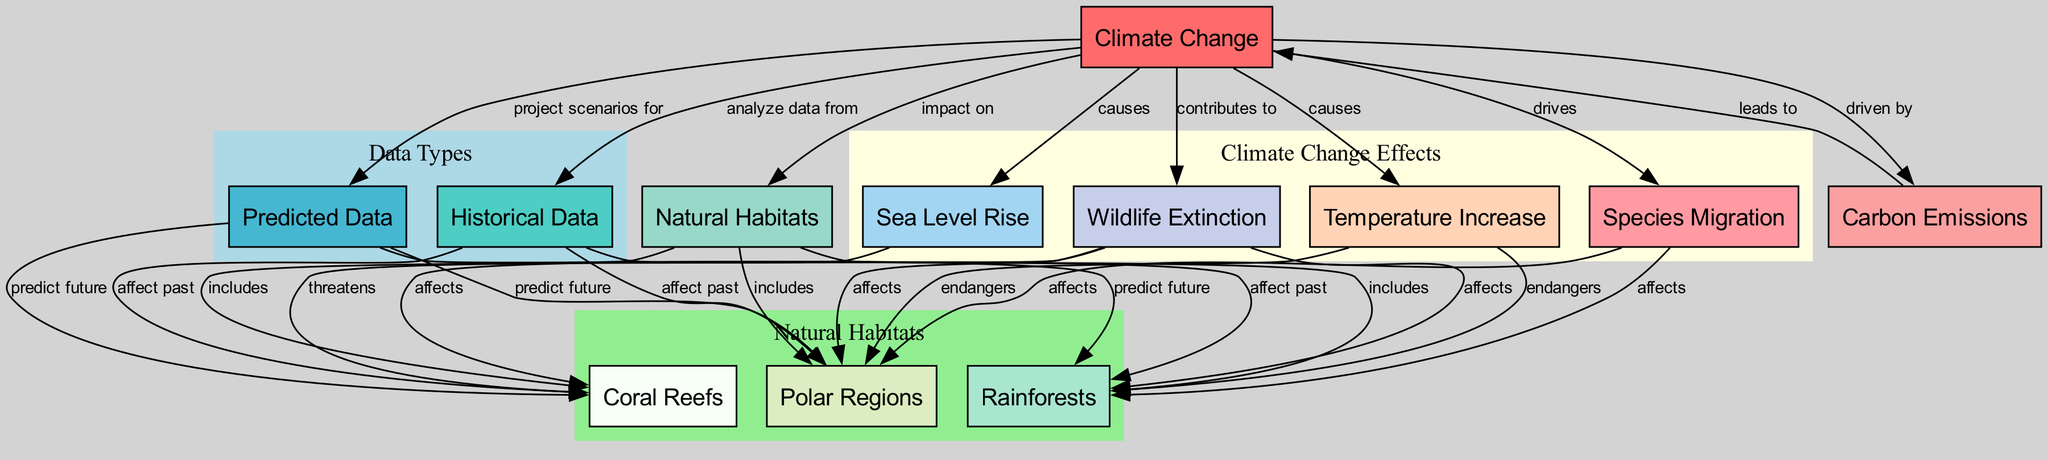What are the three natural habitats included in the diagram? The diagram shows three natural habitats: Coral Reefs, Rainforests, and Polar Regions. These are visible under the "Natural Habitats" node and explicitly listed within the edge connections.
Answer: Coral Reefs, Rainforests, Polar Regions How many edges are there in the diagram? The diagram contains a total of 25 edges connecting the various nodes. This can be counted by looking at the total relationships (edges) listed between nodes.
Answer: 25 What does "Climate Change" primarily impact? According to the diagram, "Climate Change" primarily impacts "Natural Habitats," as directly noted in the edge connecting these two nodes.
Answer: Natural Habitats What drives species migration according to the diagram? The diagram indicates that "Climate Change" drives "Species Migration," as shown in the edge connection that states "drives" between these two nodes.
Answer: Climate Change Which natural habitat is endangered by temperature increase? The diagram specifies that both "Rainforests" and "Polar Regions" are endanger by "Temperature Increase," as indicated by the edges stating "endangers" from temperature increase to these habitats.
Answer: Rainforests, Polar Regions What is a predicted effect of climate change on coral reefs? The diagram shows that the "Predicted Data" node connects to "Coral Reefs" and states "predict future." This means that changes in climate are expected to affect coral reefs in the future.
Answer: predict future What are the two main causes of climate change listed in the diagram? The diagram lists "Temperature Increase" and "Sea Level Rise" as the two main causes of "Climate Change." The edges indicate these relationships clearly.
Answer: Temperature Increase, Sea Level Rise How does carbon emissions relate to climate change in the diagram? The diagram states that "Carbon Emissions" leads to "Climate Change," indicating that higher emissions contribute directly to the progression of climate change.
Answer: leads to What does wildlife extinction contribute to according to the diagram? The diagram states that "Wildlife Extinction" contributes to the ongoing effects and consequences of "Climate Change," as noted by the edge labeled "contributes to" connecting those two nodes.
Answer: Climate Change 